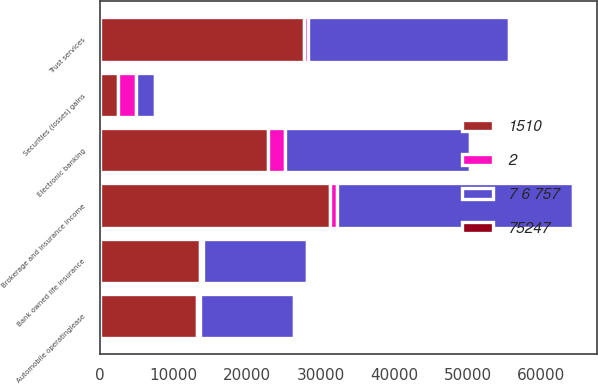Convert chart. <chart><loc_0><loc_0><loc_500><loc_500><stacked_bar_chart><ecel><fcel>Brokerage and insurance income<fcel>Trust services<fcel>Electronic banking<fcel>Bank owned life insurance<fcel>Automobile operatinglease<fcel>Securities (losses) gains<nl><fcel>7 6 757<fcel>32173<fcel>27275<fcel>25173<fcel>14055<fcel>12671<fcel>2602<nl><fcel>1510<fcel>31233<fcel>27811<fcel>22838<fcel>13577<fcel>13170<fcel>2468.5<nl><fcel>2<fcel>940<fcel>536<fcel>2335<fcel>478<fcel>499<fcel>2468.5<nl><fcel>75247<fcel>3<fcel>2<fcel>10<fcel>4<fcel>4<fcel>98<nl></chart> 